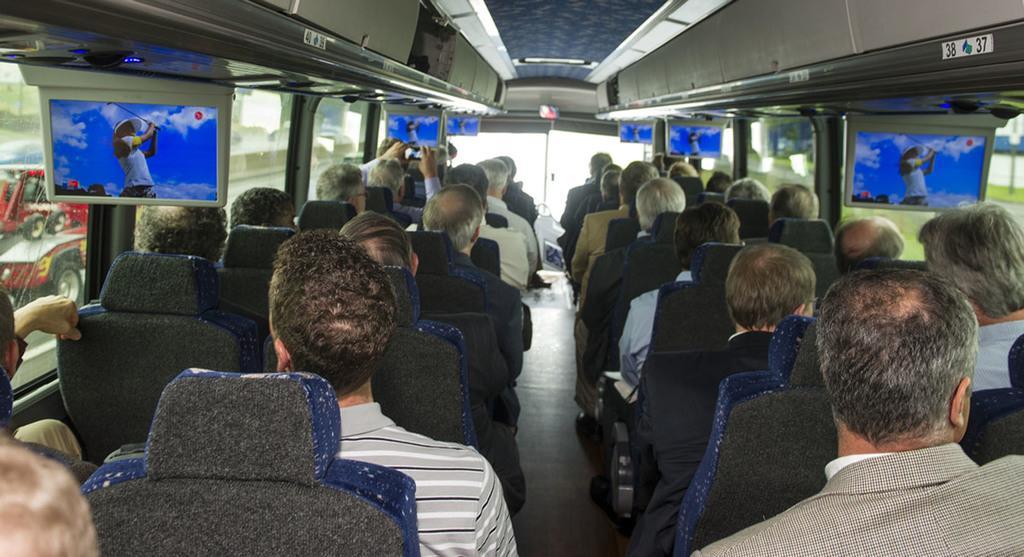Describe this image in one or two sentences. This is a picture of inside of a vehicle, in this image there are group of people sitting on chairs and there are televisions and there are glass windows. At the top there are some rocks, and on the left side of the image there are windows, through the windows we could see vehicles. 